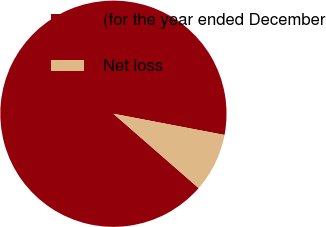<chart> <loc_0><loc_0><loc_500><loc_500><pie_chart><fcel>(for the year ended December<fcel>Net loss<nl><fcel>91.59%<fcel>8.41%<nl></chart> 